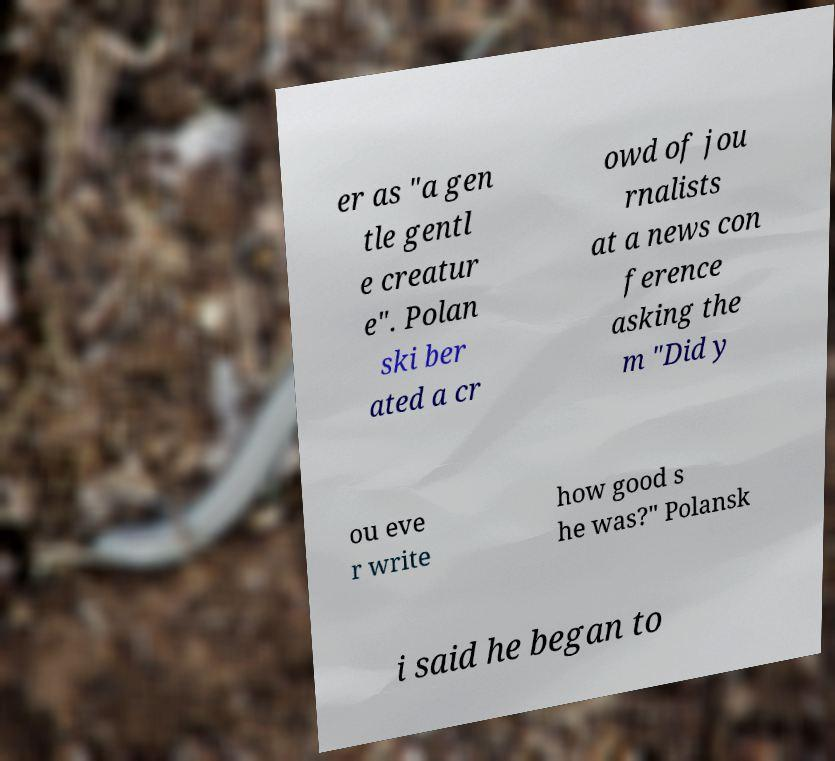I need the written content from this picture converted into text. Can you do that? er as "a gen tle gentl e creatur e". Polan ski ber ated a cr owd of jou rnalists at a news con ference asking the m "Did y ou eve r write how good s he was?" Polansk i said he began to 